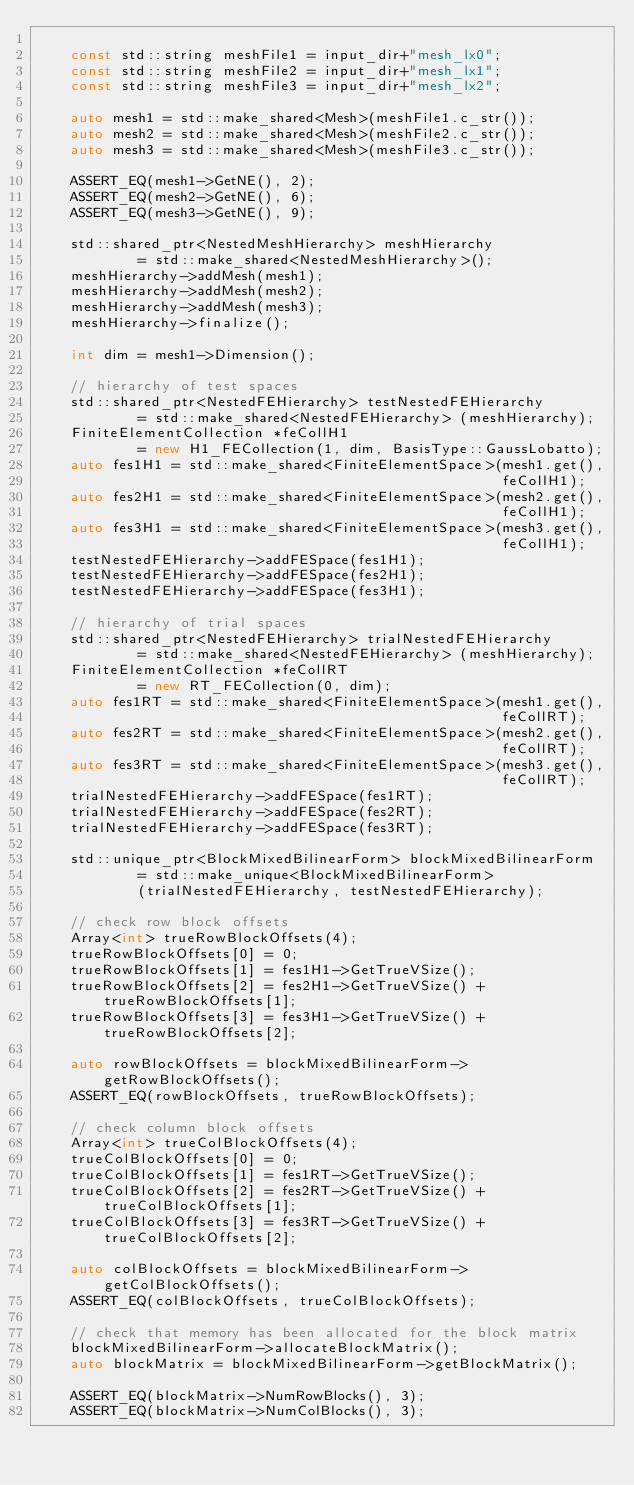<code> <loc_0><loc_0><loc_500><loc_500><_C++_>
    const std::string meshFile1 = input_dir+"mesh_lx0";
    const std::string meshFile2 = input_dir+"mesh_lx1";
    const std::string meshFile3 = input_dir+"mesh_lx2";

    auto mesh1 = std::make_shared<Mesh>(meshFile1.c_str());
    auto mesh2 = std::make_shared<Mesh>(meshFile2.c_str());
    auto mesh3 = std::make_shared<Mesh>(meshFile3.c_str());

    ASSERT_EQ(mesh1->GetNE(), 2);
    ASSERT_EQ(mesh2->GetNE(), 6);
    ASSERT_EQ(mesh3->GetNE(), 9);

    std::shared_ptr<NestedMeshHierarchy> meshHierarchy
            = std::make_shared<NestedMeshHierarchy>();
    meshHierarchy->addMesh(mesh1);
    meshHierarchy->addMesh(mesh2);
    meshHierarchy->addMesh(mesh3);
    meshHierarchy->finalize();

    int dim = mesh1->Dimension();

    // hierarchy of test spaces
    std::shared_ptr<NestedFEHierarchy> testNestedFEHierarchy
            = std::make_shared<NestedFEHierarchy> (meshHierarchy);
    FiniteElementCollection *feCollH1
            = new H1_FECollection(1, dim, BasisType::GaussLobatto);
    auto fes1H1 = std::make_shared<FiniteElementSpace>(mesh1.get(),
                                                       feCollH1);
    auto fes2H1 = std::make_shared<FiniteElementSpace>(mesh2.get(),
                                                       feCollH1);
    auto fes3H1 = std::make_shared<FiniteElementSpace>(mesh3.get(),
                                                       feCollH1);
    testNestedFEHierarchy->addFESpace(fes1H1);
    testNestedFEHierarchy->addFESpace(fes2H1);
    testNestedFEHierarchy->addFESpace(fes3H1);

    // hierarchy of trial spaces
    std::shared_ptr<NestedFEHierarchy> trialNestedFEHierarchy
            = std::make_shared<NestedFEHierarchy> (meshHierarchy);
    FiniteElementCollection *feCollRT
            = new RT_FECollection(0, dim);
    auto fes1RT = std::make_shared<FiniteElementSpace>(mesh1.get(),
                                                       feCollRT);
    auto fes2RT = std::make_shared<FiniteElementSpace>(mesh2.get(),
                                                       feCollRT);
    auto fes3RT = std::make_shared<FiniteElementSpace>(mesh3.get(),
                                                       feCollRT);
    trialNestedFEHierarchy->addFESpace(fes1RT);
    trialNestedFEHierarchy->addFESpace(fes2RT);
    trialNestedFEHierarchy->addFESpace(fes3RT);

    std::unique_ptr<BlockMixedBilinearForm> blockMixedBilinearForm
            = std::make_unique<BlockMixedBilinearForm>
            (trialNestedFEHierarchy, testNestedFEHierarchy);

    // check row block offsets
    Array<int> trueRowBlockOffsets(4);
    trueRowBlockOffsets[0] = 0;
    trueRowBlockOffsets[1] = fes1H1->GetTrueVSize();
    trueRowBlockOffsets[2] = fes2H1->GetTrueVSize() + trueRowBlockOffsets[1];
    trueRowBlockOffsets[3] = fes3H1->GetTrueVSize() + trueRowBlockOffsets[2];

    auto rowBlockOffsets = blockMixedBilinearForm->getRowBlockOffsets();
    ASSERT_EQ(rowBlockOffsets, trueRowBlockOffsets);

    // check column block offsets
    Array<int> trueColBlockOffsets(4);
    trueColBlockOffsets[0] = 0;
    trueColBlockOffsets[1] = fes1RT->GetTrueVSize();
    trueColBlockOffsets[2] = fes2RT->GetTrueVSize() + trueColBlockOffsets[1];
    trueColBlockOffsets[3] = fes3RT->GetTrueVSize() + trueColBlockOffsets[2];

    auto colBlockOffsets = blockMixedBilinearForm->getColBlockOffsets();
    ASSERT_EQ(colBlockOffsets, trueColBlockOffsets);

    // check that memory has been allocated for the block matrix
    blockMixedBilinearForm->allocateBlockMatrix();
    auto blockMatrix = blockMixedBilinearForm->getBlockMatrix();

    ASSERT_EQ(blockMatrix->NumRowBlocks(), 3);
    ASSERT_EQ(blockMatrix->NumColBlocks(), 3);</code> 